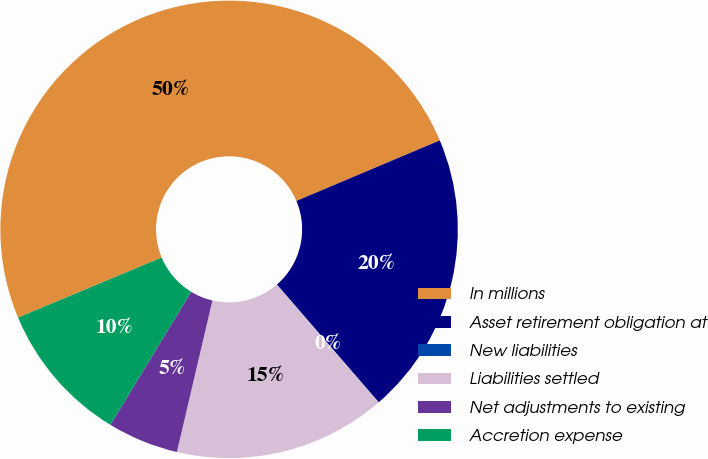<chart> <loc_0><loc_0><loc_500><loc_500><pie_chart><fcel>In millions<fcel>Asset retirement obligation at<fcel>New liabilities<fcel>Liabilities settled<fcel>Net adjustments to existing<fcel>Accretion expense<nl><fcel>49.95%<fcel>20.0%<fcel>0.02%<fcel>15.0%<fcel>5.02%<fcel>10.01%<nl></chart> 